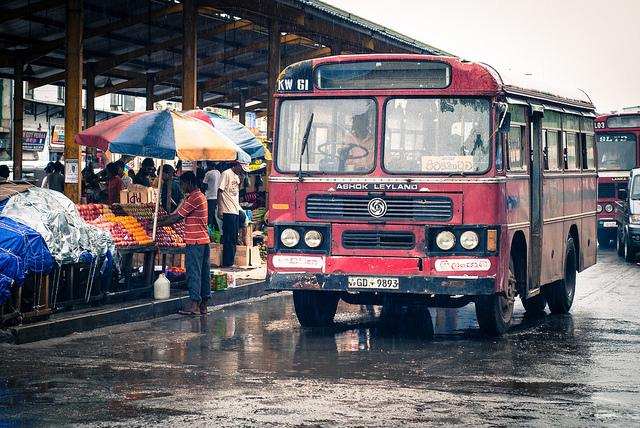What food can you buy as you get on the bus? Please explain your reasoning. fruit. There are edible plants with seeds in a stall next to the stop. 